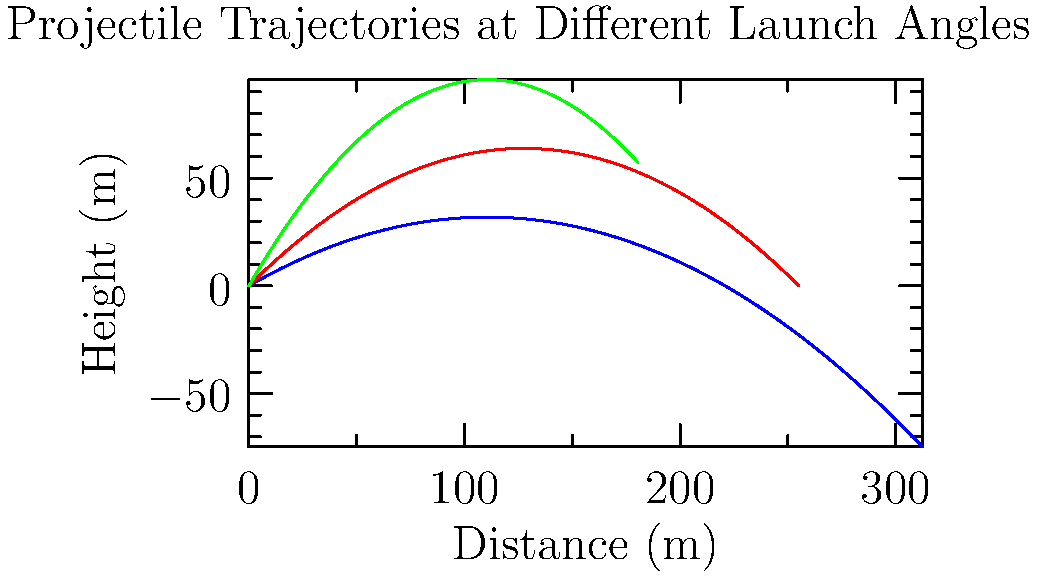As a project manager overseeing data analysis for international development projects, you're tasked with evaluating the efficiency of water distribution systems. A key component involves understanding the trajectory of water jets from sprinklers. Given the graph showing projectile trajectories at launch angles of 30°, 45°, and 60°, which angle would you recommend for maximizing the horizontal distance covered by the water, and why? To determine the optimal angle for maximizing horizontal distance, let's analyze the trajectories:

1. The blue curve represents the 30° launch angle.
2. The red curve represents the 45° launch angle.
3. The green curve represents the 60° launch angle.

Step 1: Observe the horizontal distances
- The 30° trajectory extends the furthest along the x-axis.
- The 45° trajectory reaches a medium horizontal distance.
- The 60° trajectory has the shortest horizontal reach.

Step 2: Understand the physics
The horizontal distance (range) of a projectile is given by the equation:

$$R = \frac{v_0^2 \sin(2\theta)}{g}$$

Where:
$R$ is the range
$v_0$ is the initial velocity
$\theta$ is the launch angle
$g$ is the acceleration due to gravity

Step 3: Analyze the sine function
The $\sin(2\theta)$ term reaches its maximum value of 1 when $2\theta = 90°$, or when $\theta = 45°$.

Step 4: Consider practical factors
While 45° theoretically gives the maximum range, in real-world scenarios:
- Air resistance affects higher trajectories more (60°).
- Lower angles (30°) may be more efficient for water distribution over a larger area.

Step 5: Make a recommendation
For maximizing horizontal distance in a practical water distribution system, the 30° angle would be most effective. It provides the greatest horizontal reach while minimizing water loss due to air resistance and evaporation.
Answer: 30° 